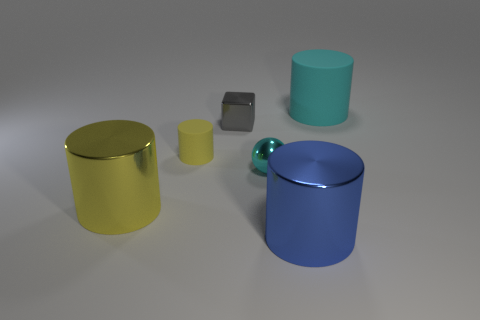Add 2 large yellow cylinders. How many objects exist? 8 Subtract all tiny cylinders. How many cylinders are left? 3 Subtract all yellow cubes. Subtract all green spheres. How many cubes are left? 1 Subtract all green cubes. How many blue cylinders are left? 1 Subtract all blue cylinders. How many cylinders are left? 3 Subtract all cylinders. How many objects are left? 2 Subtract 4 cylinders. How many cylinders are left? 0 Subtract all small cyan things. Subtract all big matte things. How many objects are left? 4 Add 3 tiny rubber things. How many tiny rubber things are left? 4 Add 4 big blue matte balls. How many big blue matte balls exist? 4 